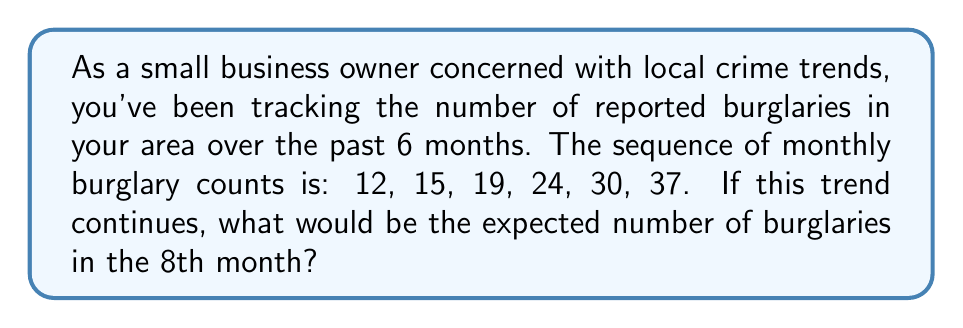What is the answer to this math problem? Let's analyze this sequence step-by-step:

1) First, we need to find the pattern in the given sequence:
   12, 15, 19, 24, 30, 37

2) Let's calculate the differences between consecutive terms:
   15 - 12 = 3
   19 - 15 = 4
   24 - 19 = 5
   30 - 24 = 6
   37 - 30 = 7

3) We can see that the differences are increasing by 1 each time:
   3, 4, 5, 6, 7

4) This suggests that we have a quadratic sequence, where the second differences are constant.

5) The next difference in the sequence would be 8, and the one after that would be 9.

6) So, to find the 7th term, we add 8 to the 6th term:
   37 + 8 = 45

7) To find the 8th term (which is what the question asks for), we add 9 to the 7th term:
   45 + 9 = 54

Therefore, if this trend continues, we would expect 54 burglaries in the 8th month.

This can be verified by fitting a quadratic function to the data, but the method shown here is more straightforward for sequence analysis.
Answer: 54 